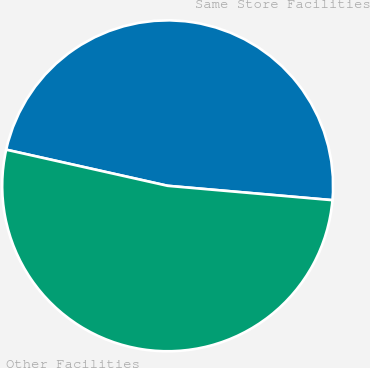Convert chart. <chart><loc_0><loc_0><loc_500><loc_500><pie_chart><fcel>Same Store Facilities<fcel>Other Facilities<nl><fcel>47.88%<fcel>52.12%<nl></chart> 